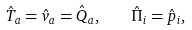<formula> <loc_0><loc_0><loc_500><loc_500>\hat { T } _ { a } = \hat { v } _ { a } = \hat { Q } _ { a } , \quad \hat { \Pi } _ { i } = \hat { p } _ { i } ,</formula> 